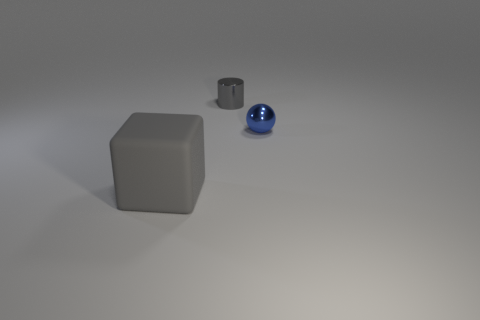Add 2 small yellow metal spheres. How many objects exist? 5 Subtract all balls. How many objects are left? 2 Subtract 1 gray cylinders. How many objects are left? 2 Subtract all spheres. Subtract all small gray cylinders. How many objects are left? 1 Add 2 blue metal things. How many blue metal things are left? 3 Add 1 tiny red shiny things. How many tiny red shiny things exist? 1 